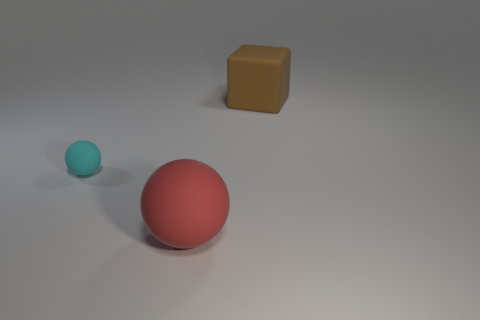Is there anything else that has the same size as the cyan rubber thing?
Offer a terse response. No. There is a red sphere that is the same size as the brown block; what is its material?
Your response must be concise. Rubber. There is a large red thing that is the same shape as the small matte thing; what is its material?
Offer a very short reply. Rubber. What number of other things are the same size as the cyan object?
Make the answer very short. 0. The large brown rubber thing has what shape?
Provide a short and direct response. Cube. There is a rubber object that is both behind the big red rubber sphere and in front of the big cube; what color is it?
Keep it short and to the point. Cyan. What material is the large cube?
Your answer should be very brief. Rubber. The big thing that is in front of the tiny rubber object has what shape?
Provide a short and direct response. Sphere. What is the color of the cube that is the same size as the red thing?
Offer a very short reply. Brown. Is the big object on the left side of the big block made of the same material as the block?
Your response must be concise. Yes. 